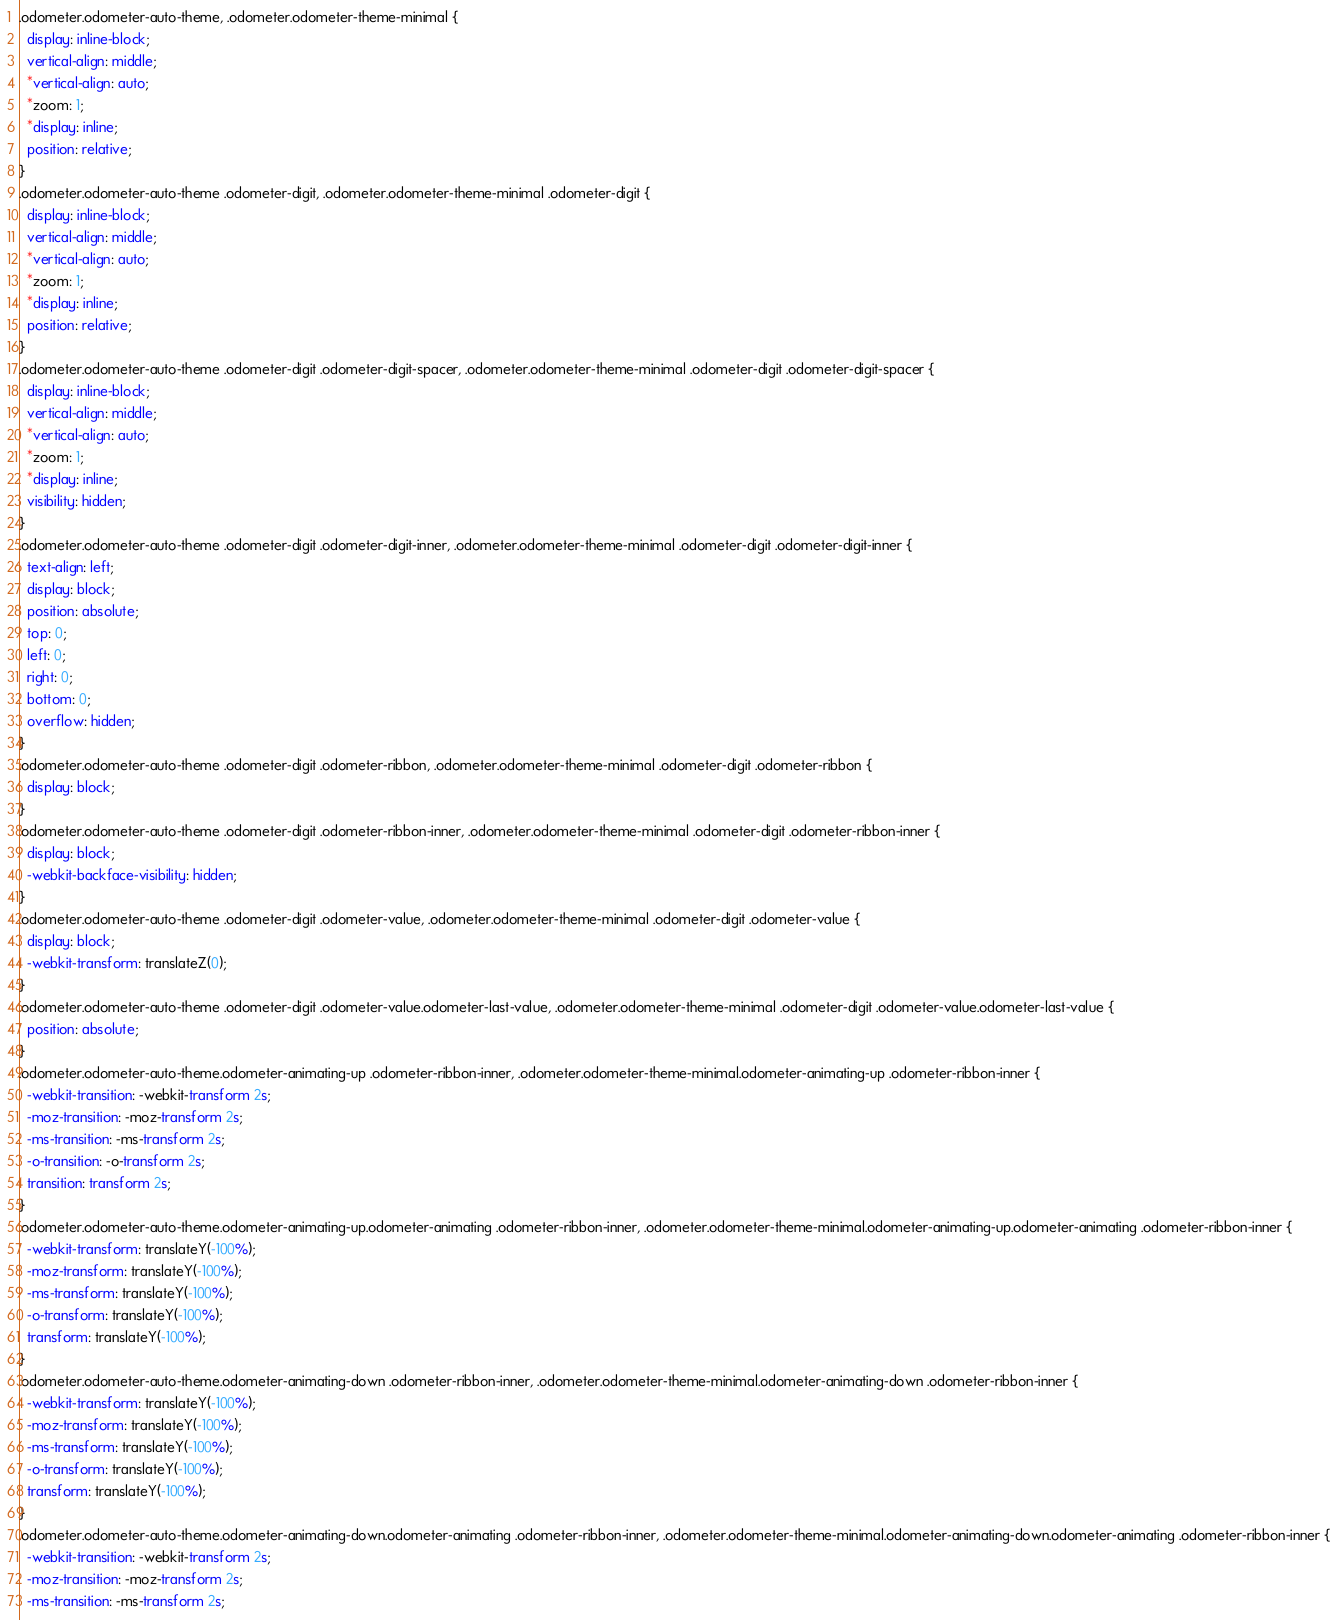<code> <loc_0><loc_0><loc_500><loc_500><_CSS_>.odometer.odometer-auto-theme, .odometer.odometer-theme-minimal {
  display: inline-block;
  vertical-align: middle;
  *vertical-align: auto;
  *zoom: 1;
  *display: inline;
  position: relative;
}
.odometer.odometer-auto-theme .odometer-digit, .odometer.odometer-theme-minimal .odometer-digit {
  display: inline-block;
  vertical-align: middle;
  *vertical-align: auto;
  *zoom: 1;
  *display: inline;
  position: relative;
}
.odometer.odometer-auto-theme .odometer-digit .odometer-digit-spacer, .odometer.odometer-theme-minimal .odometer-digit .odometer-digit-spacer {
  display: inline-block;
  vertical-align: middle;
  *vertical-align: auto;
  *zoom: 1;
  *display: inline;
  visibility: hidden;
}
.odometer.odometer-auto-theme .odometer-digit .odometer-digit-inner, .odometer.odometer-theme-minimal .odometer-digit .odometer-digit-inner {
  text-align: left;
  display: block;
  position: absolute;
  top: 0;
  left: 0;
  right: 0;
  bottom: 0;
  overflow: hidden;
}
.odometer.odometer-auto-theme .odometer-digit .odometer-ribbon, .odometer.odometer-theme-minimal .odometer-digit .odometer-ribbon {
  display: block;
}
.odometer.odometer-auto-theme .odometer-digit .odometer-ribbon-inner, .odometer.odometer-theme-minimal .odometer-digit .odometer-ribbon-inner {
  display: block;
  -webkit-backface-visibility: hidden;
}
.odometer.odometer-auto-theme .odometer-digit .odometer-value, .odometer.odometer-theme-minimal .odometer-digit .odometer-value {
  display: block;
  -webkit-transform: translateZ(0);
}
.odometer.odometer-auto-theme .odometer-digit .odometer-value.odometer-last-value, .odometer.odometer-theme-minimal .odometer-digit .odometer-value.odometer-last-value {
  position: absolute;
}
.odometer.odometer-auto-theme.odometer-animating-up .odometer-ribbon-inner, .odometer.odometer-theme-minimal.odometer-animating-up .odometer-ribbon-inner {
  -webkit-transition: -webkit-transform 2s;
  -moz-transition: -moz-transform 2s;
  -ms-transition: -ms-transform 2s;
  -o-transition: -o-transform 2s;
  transition: transform 2s;
}
.odometer.odometer-auto-theme.odometer-animating-up.odometer-animating .odometer-ribbon-inner, .odometer.odometer-theme-minimal.odometer-animating-up.odometer-animating .odometer-ribbon-inner {
  -webkit-transform: translateY(-100%);
  -moz-transform: translateY(-100%);
  -ms-transform: translateY(-100%);
  -o-transform: translateY(-100%);
  transform: translateY(-100%);
}
.odometer.odometer-auto-theme.odometer-animating-down .odometer-ribbon-inner, .odometer.odometer-theme-minimal.odometer-animating-down .odometer-ribbon-inner {
  -webkit-transform: translateY(-100%);
  -moz-transform: translateY(-100%);
  -ms-transform: translateY(-100%);
  -o-transform: translateY(-100%);
  transform: translateY(-100%);
}
.odometer.odometer-auto-theme.odometer-animating-down.odometer-animating .odometer-ribbon-inner, .odometer.odometer-theme-minimal.odometer-animating-down.odometer-animating .odometer-ribbon-inner {
  -webkit-transition: -webkit-transform 2s;
  -moz-transition: -moz-transform 2s;
  -ms-transition: -ms-transform 2s;</code> 